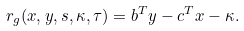Convert formula to latex. <formula><loc_0><loc_0><loc_500><loc_500>r _ { g } ( x , y , s , \kappa , \tau ) = { { b } ^ { T } } y - { { c } ^ { T } } x - \kappa .</formula> 